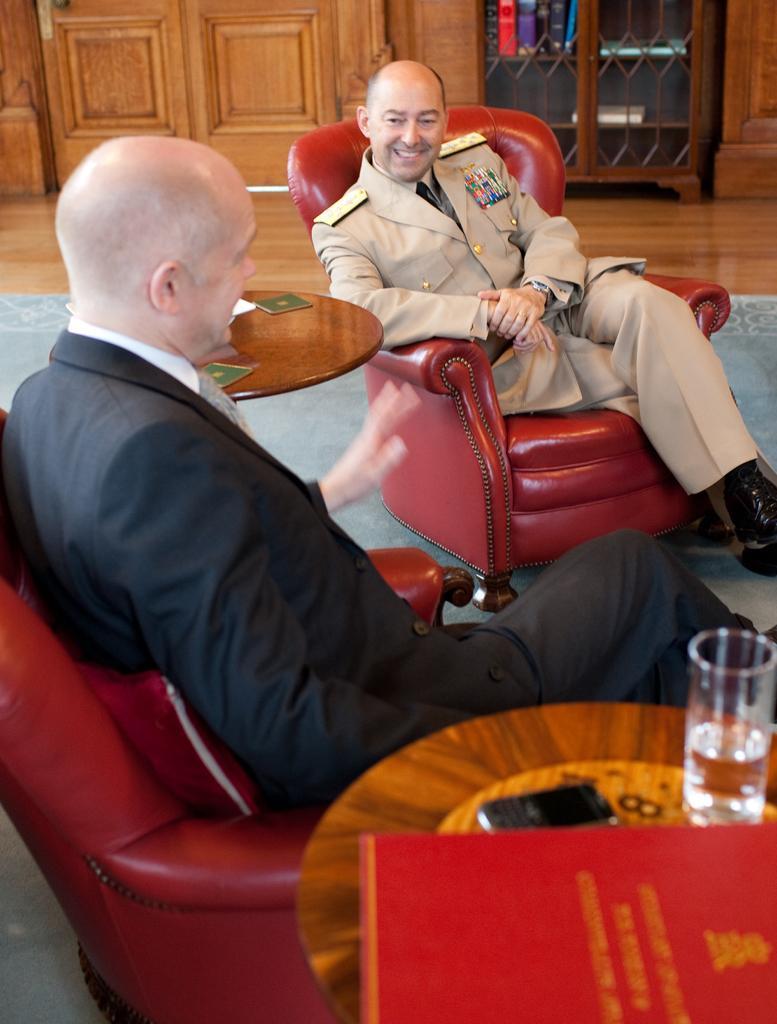Describe this image in one or two sentences. In this image, we can see two men sitting on the sofas, there is a table, we can see a water glass and a book on the table. In the background, we can see a wooden object. 